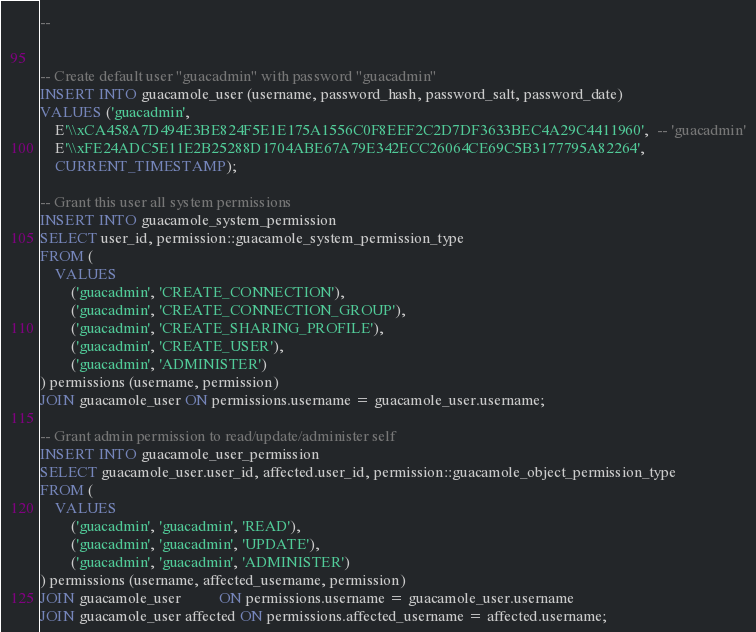<code> <loc_0><loc_0><loc_500><loc_500><_SQL_>--


-- Create default user "guacadmin" with password "guacadmin"
INSERT INTO guacamole_user (username, password_hash, password_salt, password_date)
VALUES ('guacadmin',
    E'\\xCA458A7D494E3BE824F5E1E175A1556C0F8EEF2C2D7DF3633BEC4A29C4411960',  -- 'guacadmin'
    E'\\xFE24ADC5E11E2B25288D1704ABE67A79E342ECC26064CE69C5B3177795A82264',
    CURRENT_TIMESTAMP);

-- Grant this user all system permissions
INSERT INTO guacamole_system_permission
SELECT user_id, permission::guacamole_system_permission_type
FROM (
    VALUES
        ('guacadmin', 'CREATE_CONNECTION'),
        ('guacadmin', 'CREATE_CONNECTION_GROUP'),
        ('guacadmin', 'CREATE_SHARING_PROFILE'),
        ('guacadmin', 'CREATE_USER'),
        ('guacadmin', 'ADMINISTER')
) permissions (username, permission)
JOIN guacamole_user ON permissions.username = guacamole_user.username;

-- Grant admin permission to read/update/administer self
INSERT INTO guacamole_user_permission
SELECT guacamole_user.user_id, affected.user_id, permission::guacamole_object_permission_type
FROM (
    VALUES
        ('guacadmin', 'guacadmin', 'READ'),
        ('guacadmin', 'guacadmin', 'UPDATE'),
        ('guacadmin', 'guacadmin', 'ADMINISTER')
) permissions (username, affected_username, permission)
JOIN guacamole_user          ON permissions.username = guacamole_user.username
JOIN guacamole_user affected ON permissions.affected_username = affected.username;

</code> 